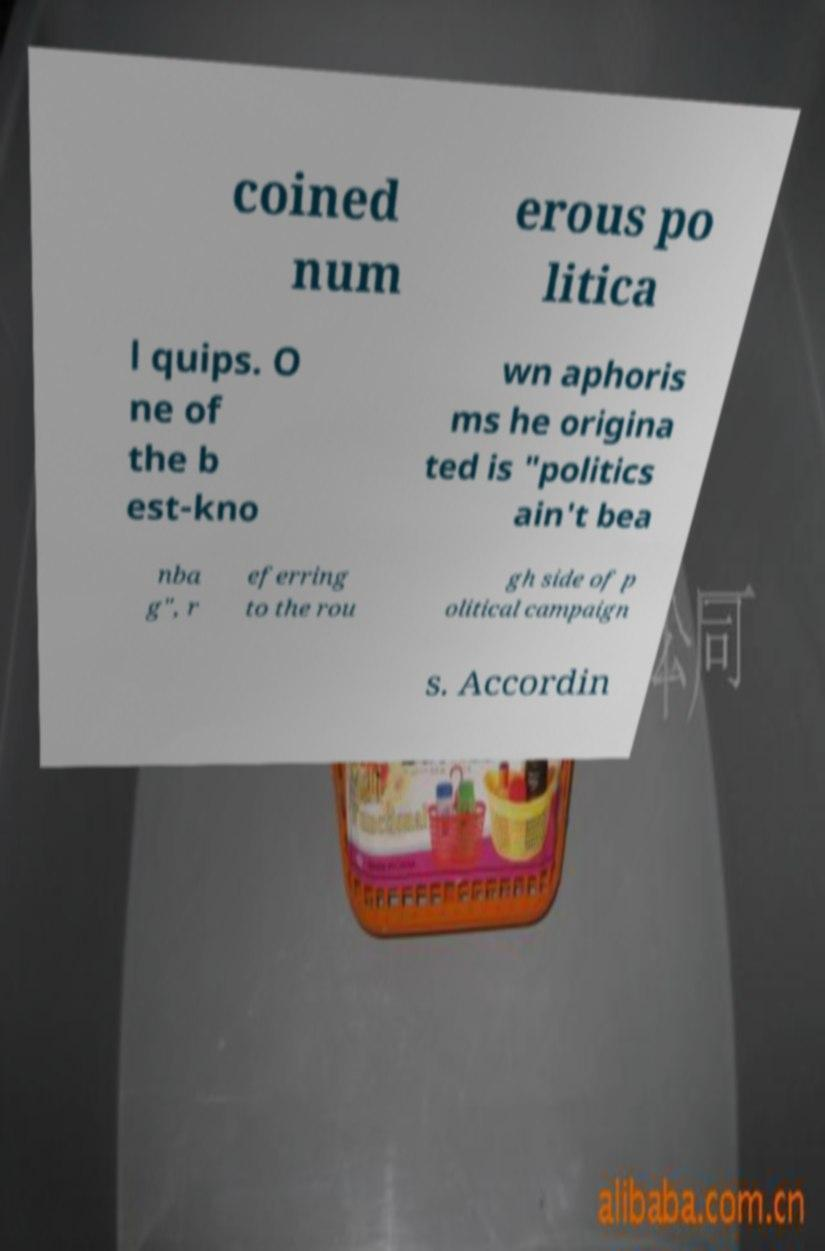Can you accurately transcribe the text from the provided image for me? coined num erous po litica l quips. O ne of the b est-kno wn aphoris ms he origina ted is "politics ain't bea nba g", r eferring to the rou gh side of p olitical campaign s. Accordin 